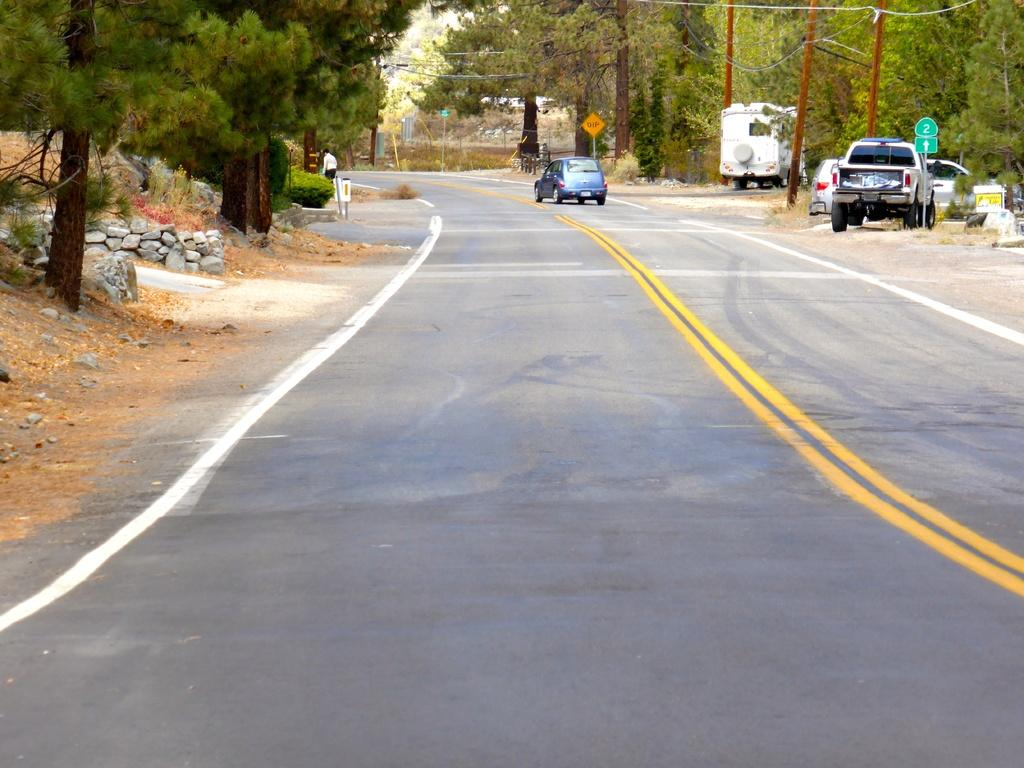What type of infrastructure is visible in the image? There are roads in the image. What type of transportation is present in the image? There are vehicles in the image. What type of natural elements can be seen in the image? There are trees in the image. What type of geological elements can be seen in the image? There are rocks in the image. What type of man-made structures can be seen in the image? There are poles in the image. What type of utility infrastructure can be seen in the image? There are cables in the image. What type of informational signage can be seen in the image? There are sign boards in the image. Can you tell me how many goose are sitting on the hospital bed in the image? There is no hospital or goose present in the image. What type of nail is being used to hang the sign board in the image? There is no nail visible in the image; the sign board is attached to the pole using cables. 